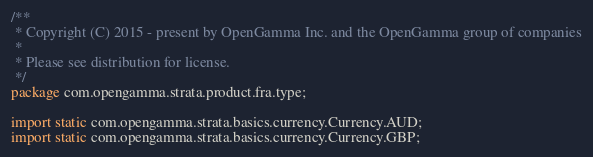<code> <loc_0><loc_0><loc_500><loc_500><_Java_>/**
 * Copyright (C) 2015 - present by OpenGamma Inc. and the OpenGamma group of companies
 *
 * Please see distribution for license.
 */
package com.opengamma.strata.product.fra.type;

import static com.opengamma.strata.basics.currency.Currency.AUD;
import static com.opengamma.strata.basics.currency.Currency.GBP;</code> 